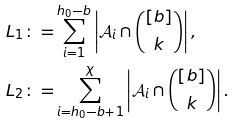Convert formula to latex. <formula><loc_0><loc_0><loc_500><loc_500>L _ { 1 } \colon = & \sum _ { i = 1 } ^ { h _ { 0 } - b } \left | \mathcal { A } _ { i } \cap \binom { [ b ] } { k } \right | , \\ L _ { 2 } \colon = & \sum _ { i = h _ { 0 } - b + 1 } ^ { \chi } \left | \mathcal { A } _ { i } \cap \binom { [ b ] } { k } \right | .</formula> 